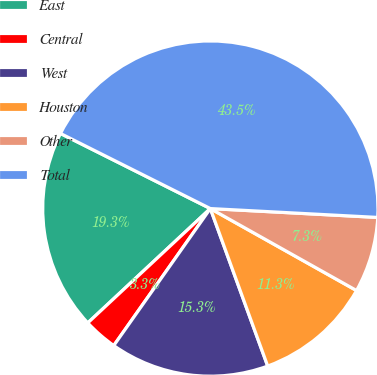Convert chart. <chart><loc_0><loc_0><loc_500><loc_500><pie_chart><fcel>East<fcel>Central<fcel>West<fcel>Houston<fcel>Other<fcel>Total<nl><fcel>19.34%<fcel>3.28%<fcel>15.33%<fcel>11.31%<fcel>7.29%<fcel>43.45%<nl></chart> 